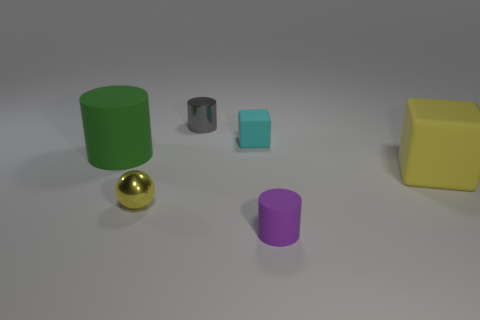Subtract all small cylinders. How many cylinders are left? 1 Subtract all balls. How many objects are left? 5 Add 1 purple blocks. How many objects exist? 7 Subtract all yellow blocks. How many blocks are left? 1 Subtract 2 cylinders. How many cylinders are left? 1 Add 1 large yellow rubber cubes. How many large yellow rubber cubes are left? 2 Add 3 tiny objects. How many tiny objects exist? 7 Subtract 0 blue cylinders. How many objects are left? 6 Subtract all gray cubes. Subtract all gray spheres. How many cubes are left? 2 Subtract all large red matte blocks. Subtract all tiny metallic objects. How many objects are left? 4 